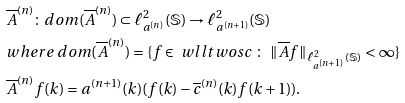<formula> <loc_0><loc_0><loc_500><loc_500>& \overline { A } ^ { ( n ) } \colon d o m ( \overline { A } ^ { ( n ) } ) \subset \ell _ { { a } ^ { ( n ) } } ^ { 2 } ( \mathbb { S } ) \to \ell _ { { a } ^ { ( n + 1 ) } } ^ { 2 } ( \mathbb { S } ) \\ & w h e r e \ d o m ( \overline { A } ^ { ( n ) } ) = \{ f \in \ w l l t w o s c \ \colon \ \| \overline { A } f \| _ { \ell _ { { a } ^ { ( n + 1 ) } } ^ { 2 } ( \mathbb { S } ) } < \infty \} \\ & \overline { A } ^ { ( n ) } f ( k ) = { a } ^ { ( n + 1 ) } ( k ) ( f ( k ) - \overline { c } ^ { ( n ) } ( k ) f ( k + 1 ) ) .</formula> 